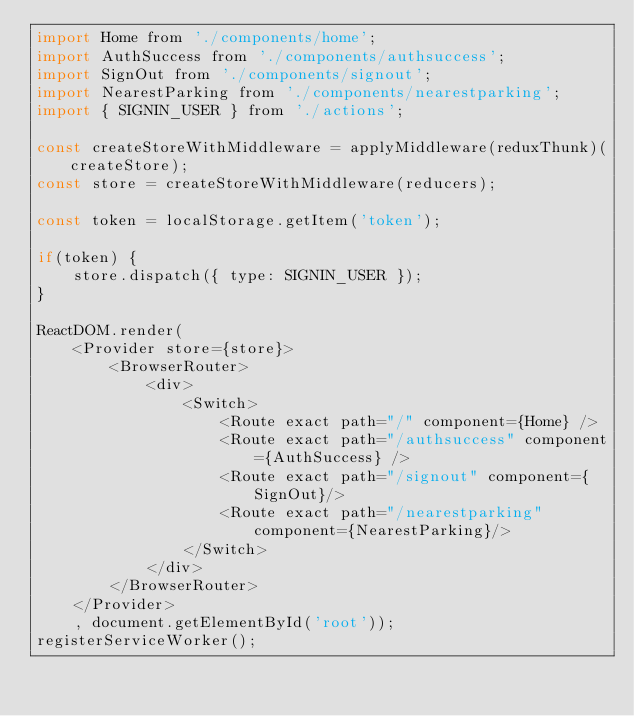<code> <loc_0><loc_0><loc_500><loc_500><_JavaScript_>import Home from './components/home';
import AuthSuccess from './components/authsuccess';
import SignOut from './components/signout';
import NearestParking from './components/nearestparking';
import { SIGNIN_USER } from './actions';

const createStoreWithMiddleware = applyMiddleware(reduxThunk)(createStore);
const store = createStoreWithMiddleware(reducers);

const token = localStorage.getItem('token');

if(token) {
    store.dispatch({ type: SIGNIN_USER });
}

ReactDOM.render(
    <Provider store={store}>
        <BrowserRouter>
            <div>
                <Switch>
                    <Route exact path="/" component={Home} />
                    <Route exact path="/authsuccess" component={AuthSuccess} />
                    <Route exact path="/signout" component={SignOut}/>
                    <Route exact path="/nearestparking" component={NearestParking}/>
                </Switch>
            </div>
        </BrowserRouter>
    </Provider>
    , document.getElementById('root'));
registerServiceWorker();
</code> 